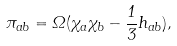<formula> <loc_0><loc_0><loc_500><loc_500>\pi _ { a b } = \Omega ( { \chi } _ { a } \chi _ { b } - \frac { 1 } { 3 } h _ { a b } ) ,</formula> 